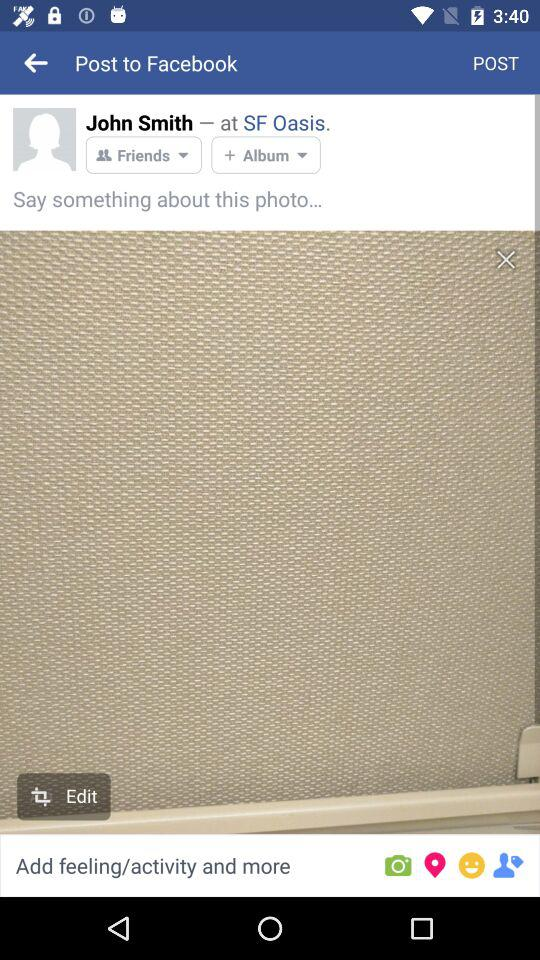What is the mentioned location? The mentioned location is SF Oasis. 